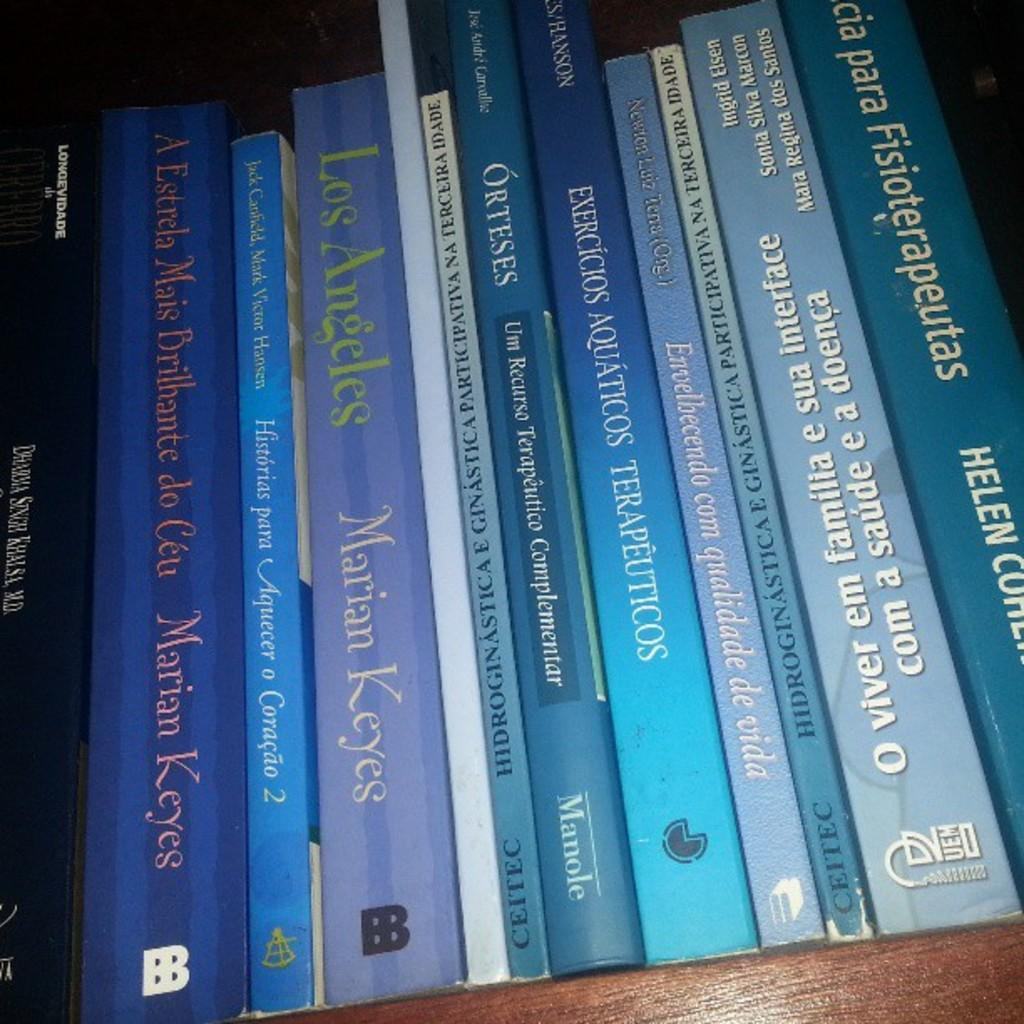<image>
Share a concise interpretation of the image provided. A stack of books, most of which were written by Marian Keyes. 